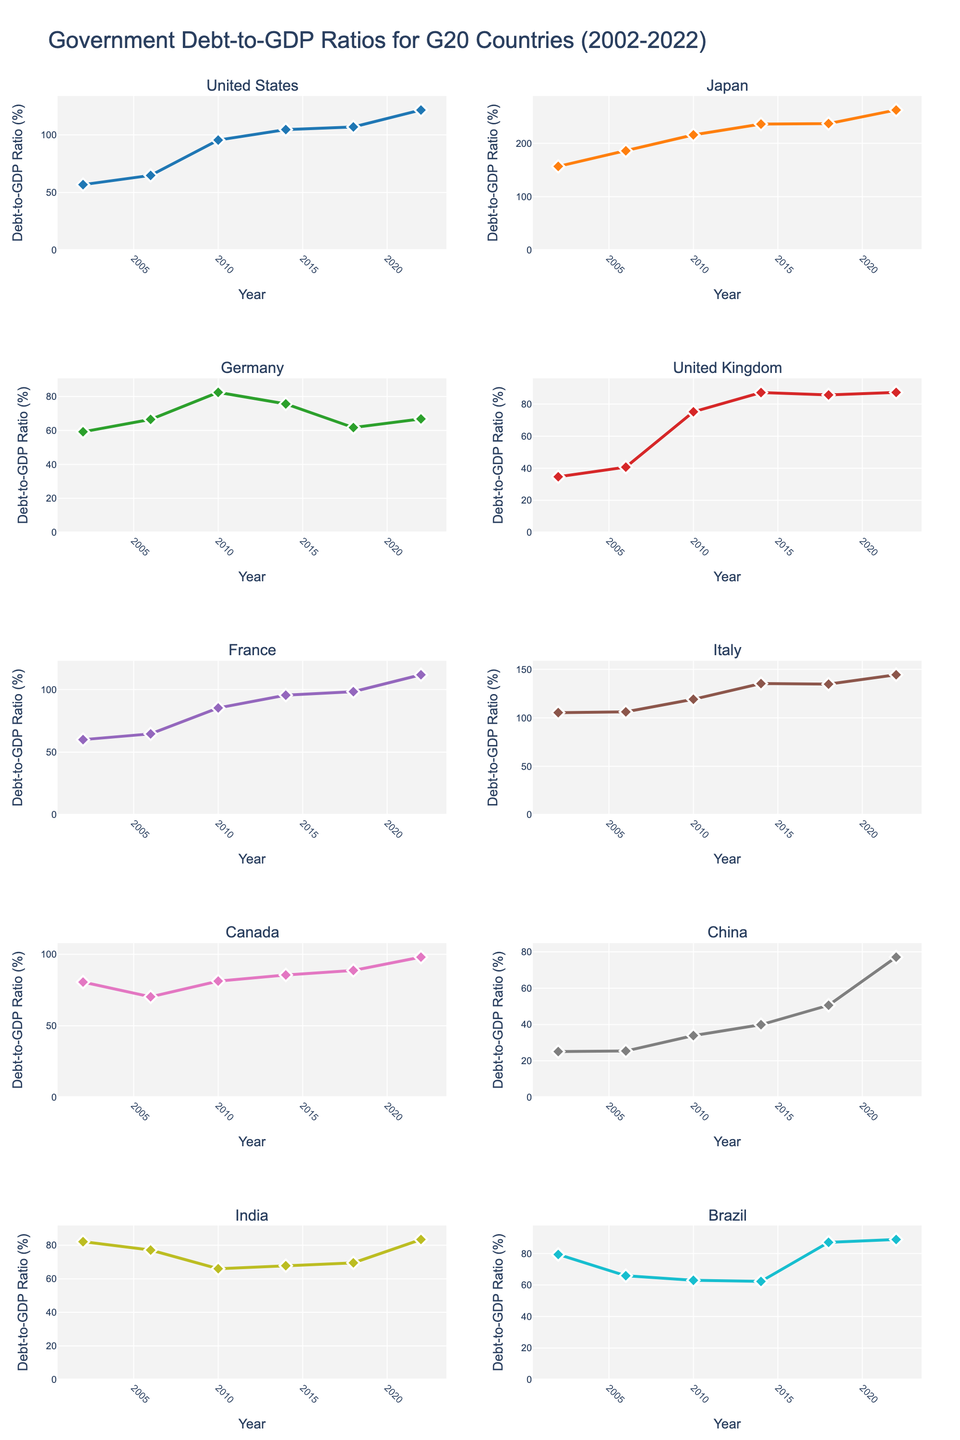What is the title of the figure? The title of a figure is typically found at the top. The title in this instance reads "Government Debt-to-GDP Ratios for G20 Countries (2002-2022)".
Answer: Government Debt-to-GDP Ratios for G20 Countries (2002-2022) Which country's debt-to-GDP ratio peaked the highest? To find the peak, look for the highest point on any of the subplots. Japan's subplot has the highest value, peaking at 262.5% in 2022.
Answer: Japan What is the general trend of the United States' debt-to-GDP ratio from 2002 to 2022? Observe the line trend in the subplot for the United States. The line generally trends upwards from 56.8% in 2002 to 121.6% in 2022.
Answer: Upward What is the difference in debt-to-GDP ratio for Brazil between 2002 and 2022? Subtract the value in 2002 (79.4%) from the value in 2022 (88.9%) to find the difference: 88.9 - 79.4 = 9.5%.
Answer: 9.5% Which country had the lowest debt-to-GDP ratio in 2002? By comparing the y-axis values of the subplots at the year 2002, China has the lowest debt-to-GDP ratio at 25.1%.
Answer: China Which countries show a decreasing trend in debt-to-GDP ratio between 2010 and 2018? Check the trend lines for each country between the years 2010 and 2018. Germany and India show a decreasing trend in this period.
Answer: Germany and India What is the average debt-to-GDP ratio for France in 2018 and 2022? Add the values for France in 2018 (98.3%) and 2022 (111.8%) and divide by 2: (98.3 + 111.8) / 2 = 105.05%.
Answer: 105.05% Which country shows the highest increase in debt-to-GDP ratio from 2006 to 2010? Calculate the difference between 2010 and 2006 for each country, then compare these differences. The United States shows the highest increase: 95.5 - 64.8 = 30.7%.
Answer: United States In which year did Canada's debt-to-GDP ratio start increasing and continued to rise till 2022? Examine the trend line for Canada and look for the point where the trend consistently starts increasing until 2022. The ratio starts increasing in 2010 and continues to rise till 2022.
Answer: 2010 